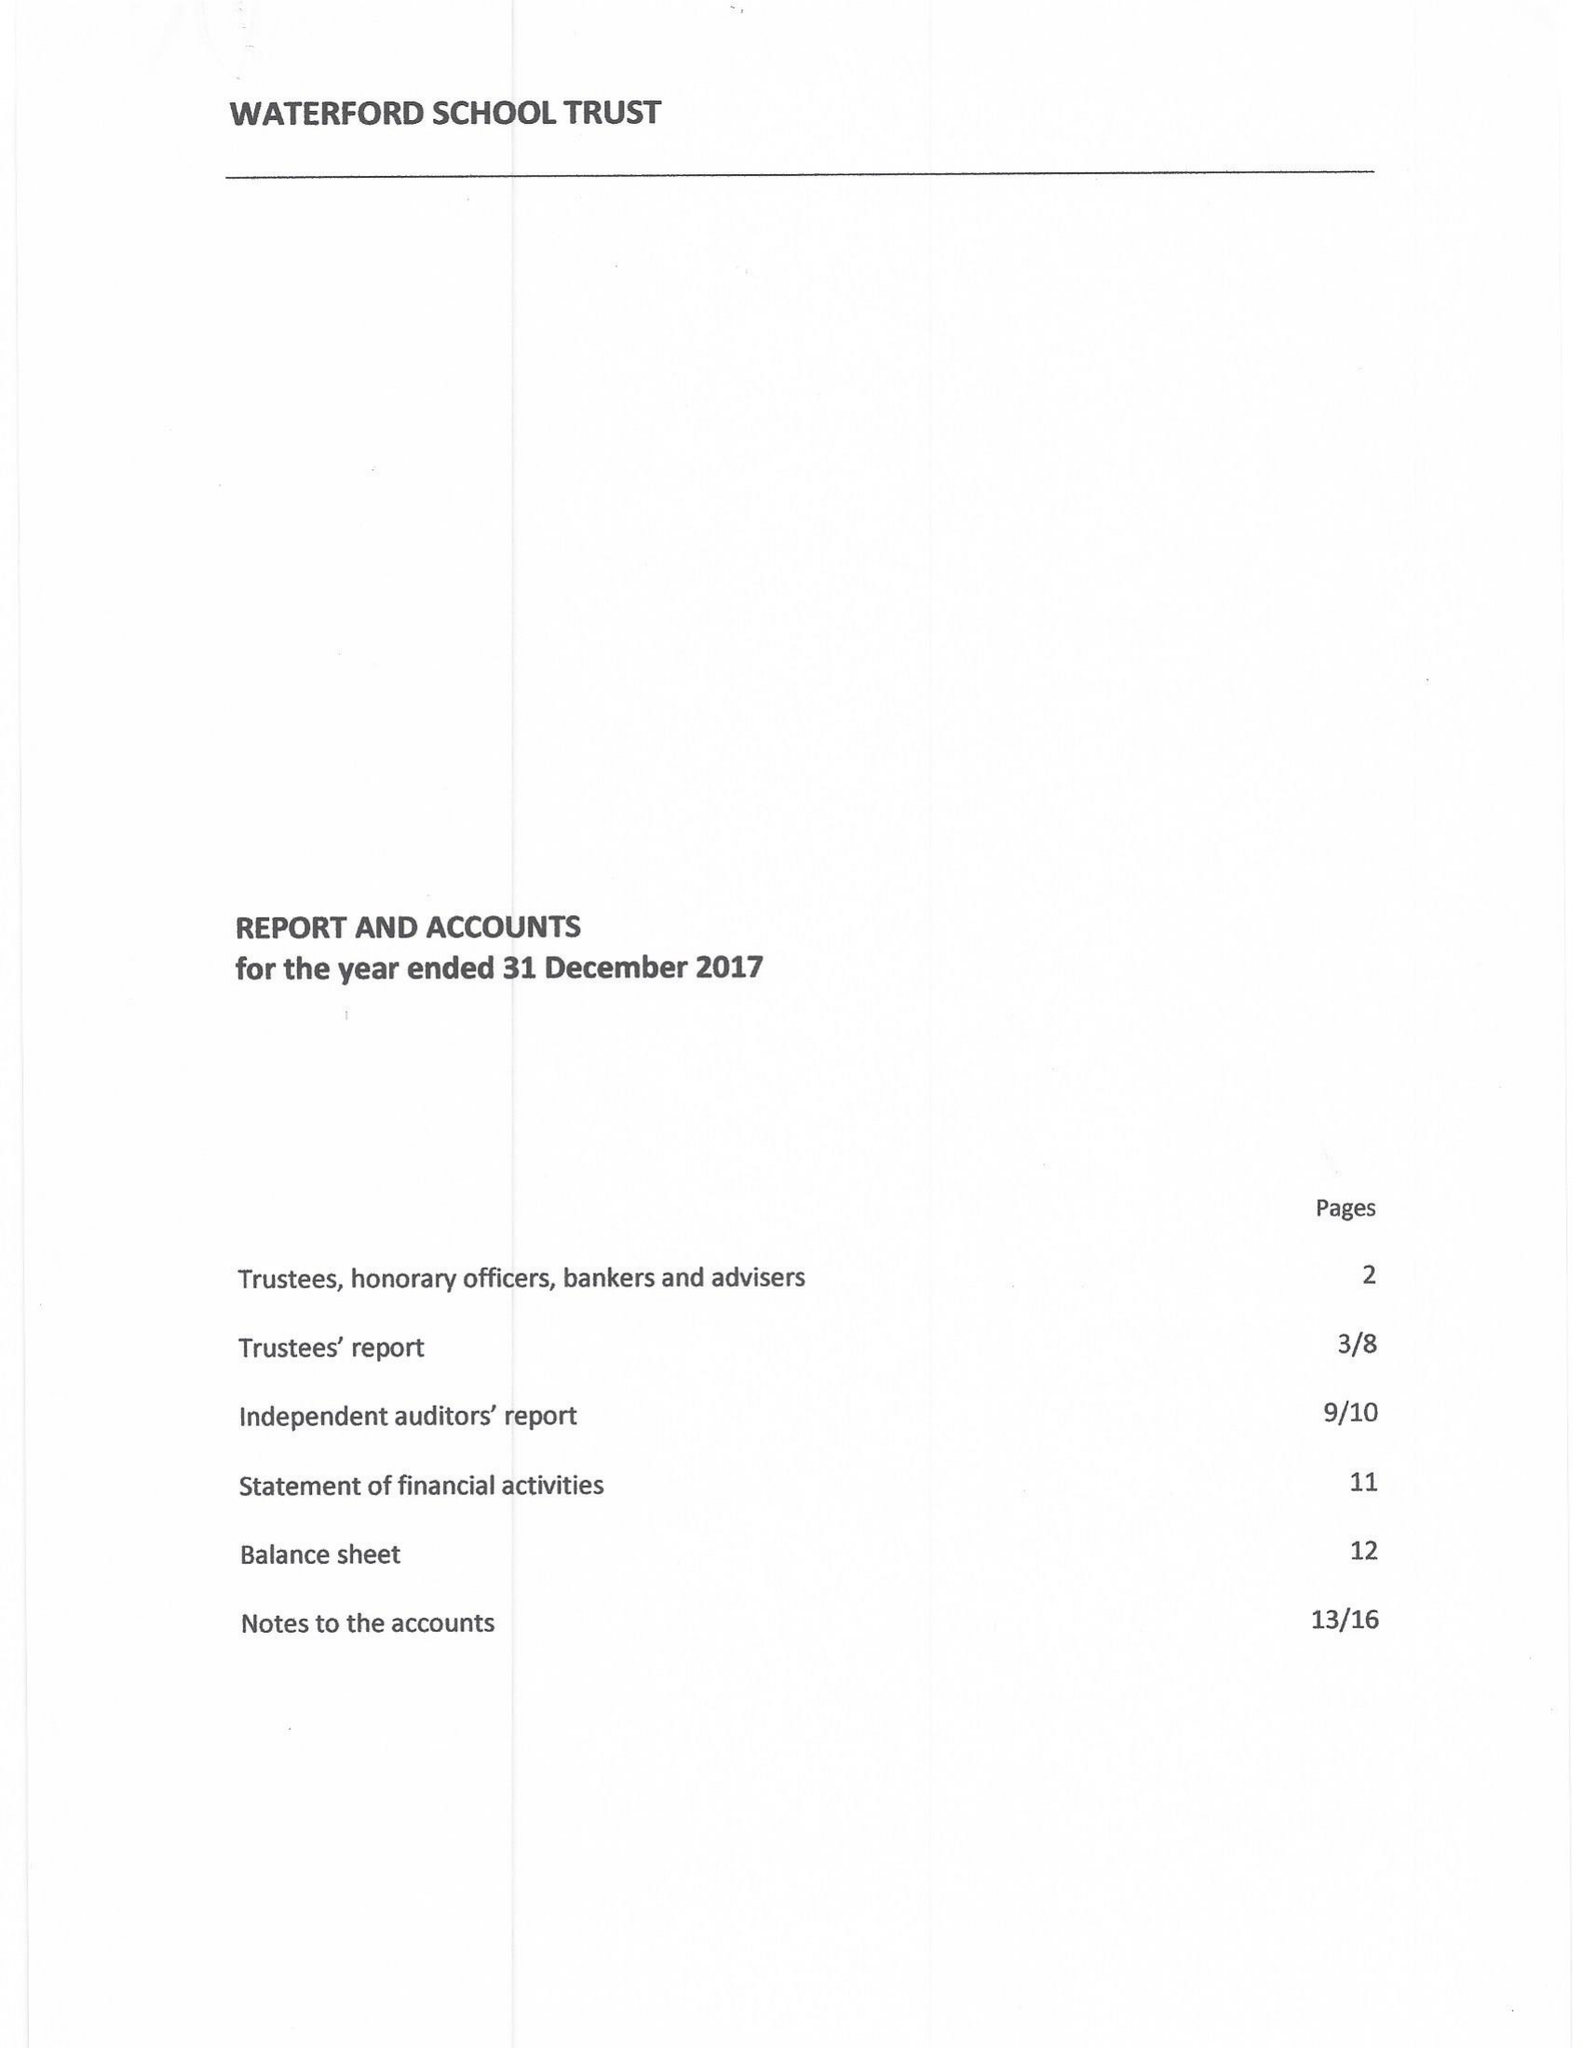What is the value for the address__postcode?
Answer the question using a single word or phrase. NW5 1BJ 